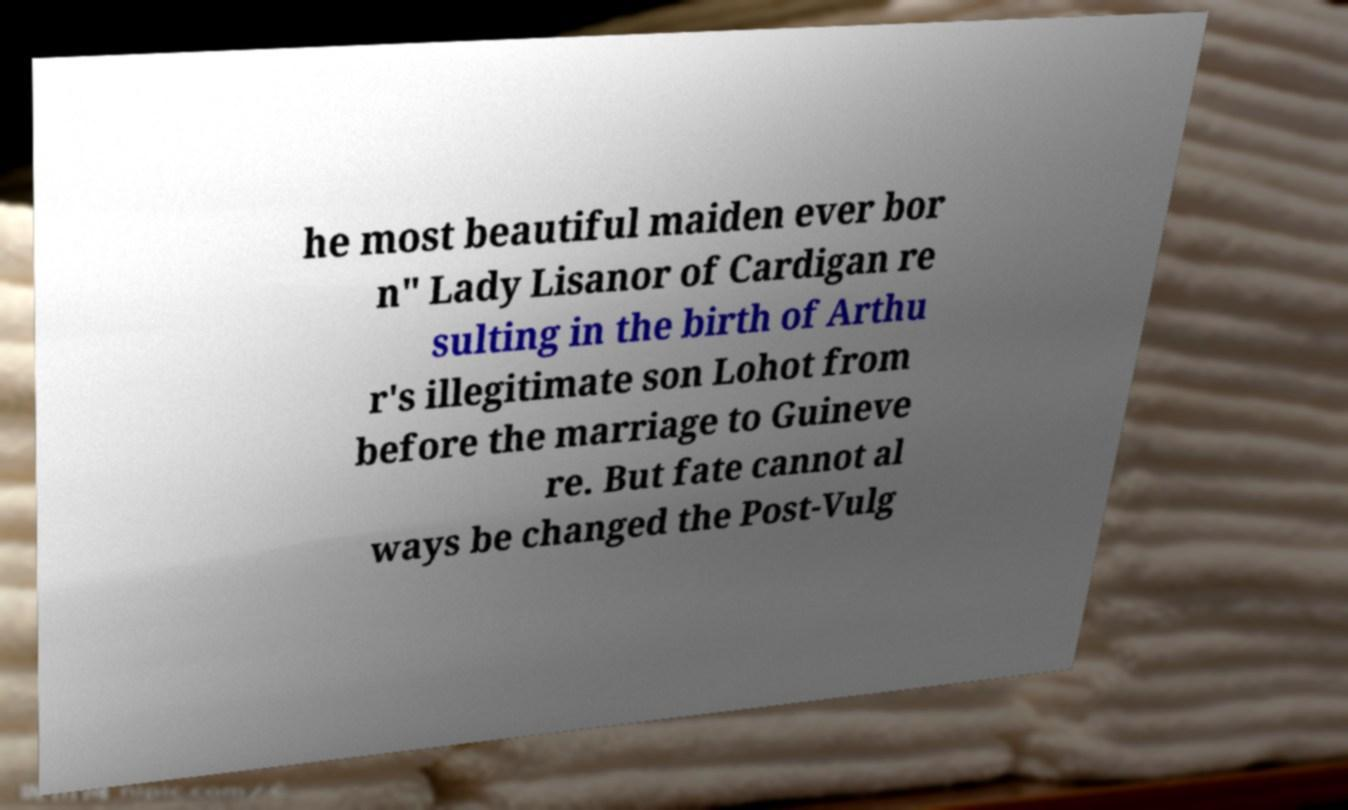Can you read and provide the text displayed in the image?This photo seems to have some interesting text. Can you extract and type it out for me? he most beautiful maiden ever bor n" Lady Lisanor of Cardigan re sulting in the birth of Arthu r's illegitimate son Lohot from before the marriage to Guineve re. But fate cannot al ways be changed the Post-Vulg 